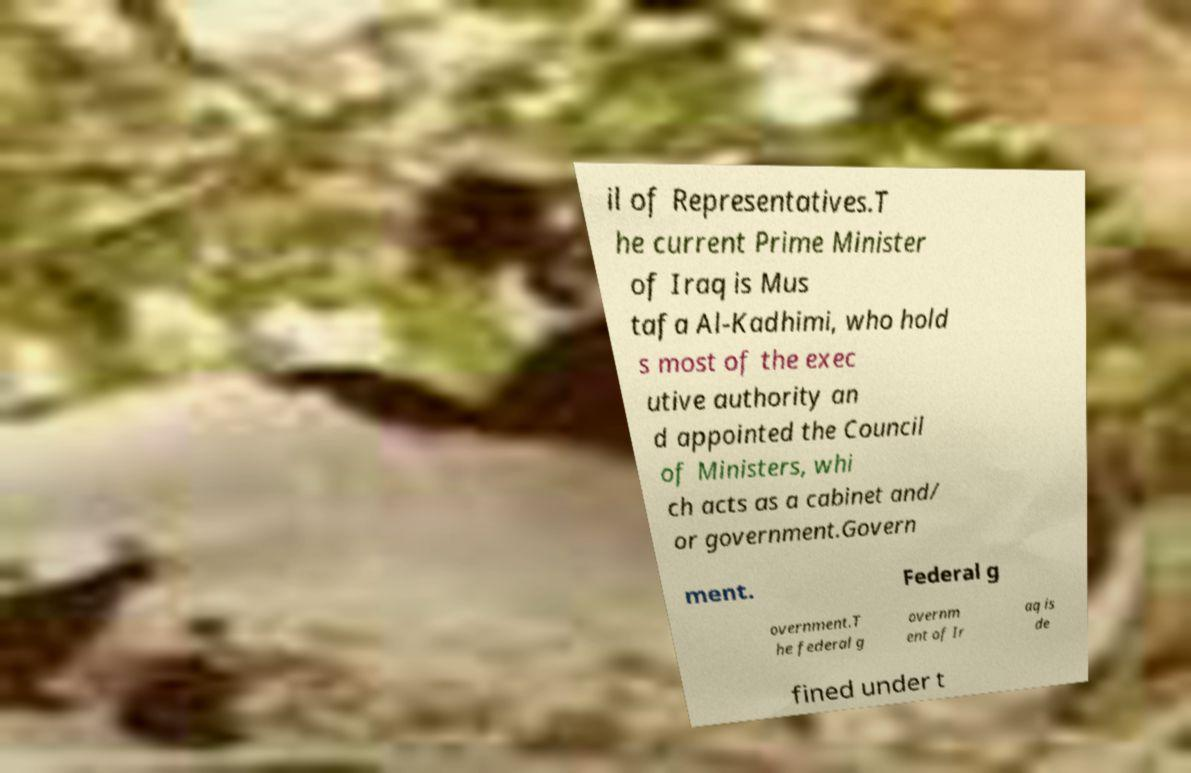For documentation purposes, I need the text within this image transcribed. Could you provide that? il of Representatives.T he current Prime Minister of Iraq is Mus tafa Al-Kadhimi, who hold s most of the exec utive authority an d appointed the Council of Ministers, whi ch acts as a cabinet and/ or government.Govern ment. Federal g overnment.T he federal g overnm ent of Ir aq is de fined under t 